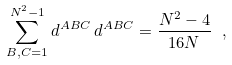<formula> <loc_0><loc_0><loc_500><loc_500>\sum _ { B , C = 1 } ^ { N ^ { 2 } - 1 } d ^ { A B C } \, d ^ { A B C } = \frac { N ^ { 2 } - 4 } { 1 6 N } \ ,</formula> 